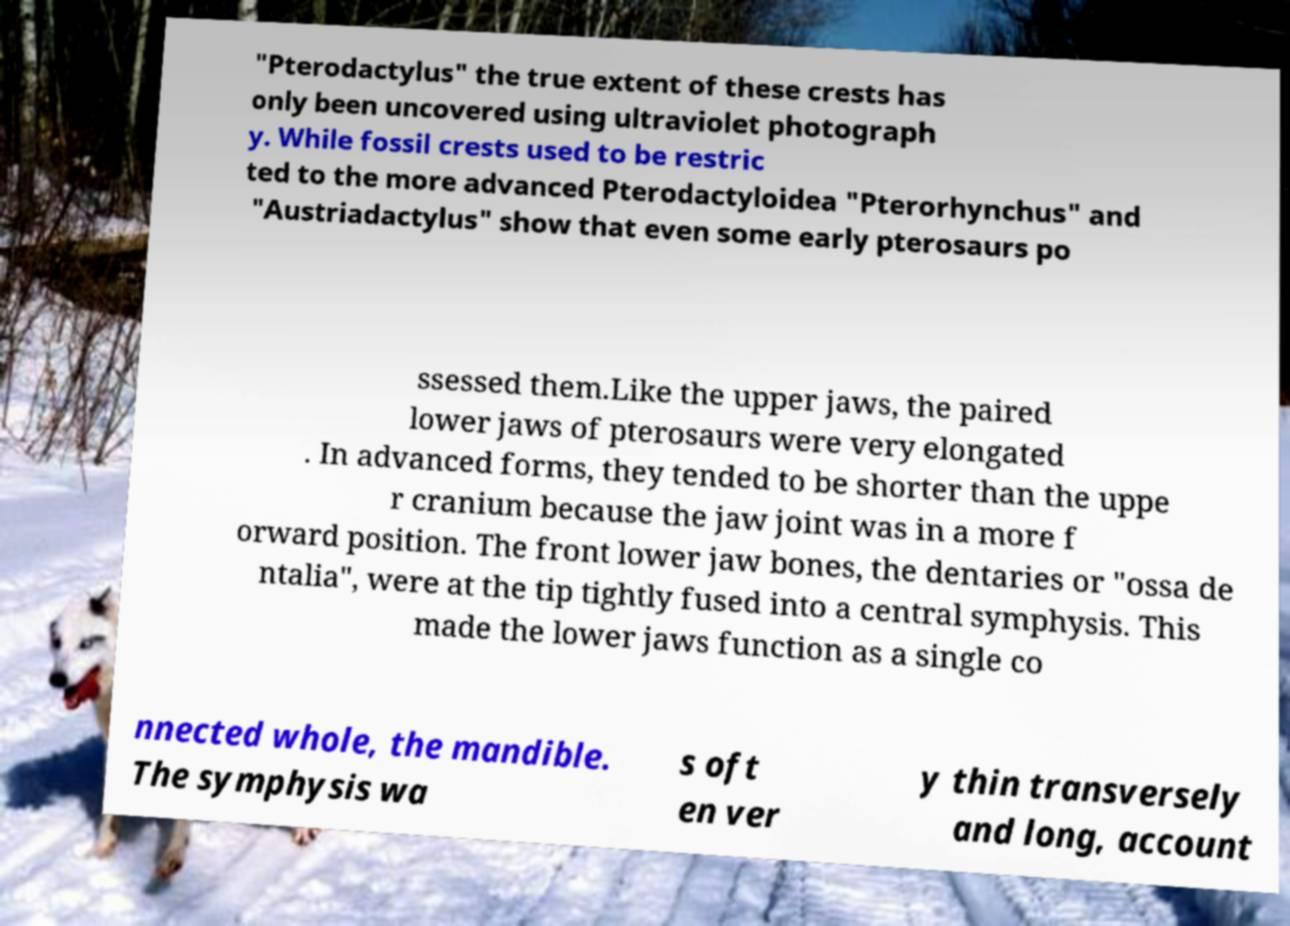Please identify and transcribe the text found in this image. "Pterodactylus" the true extent of these crests has only been uncovered using ultraviolet photograph y. While fossil crests used to be restric ted to the more advanced Pterodactyloidea "Pterorhynchus" and "Austriadactylus" show that even some early pterosaurs po ssessed them.Like the upper jaws, the paired lower jaws of pterosaurs were very elongated . In advanced forms, they tended to be shorter than the uppe r cranium because the jaw joint was in a more f orward position. The front lower jaw bones, the dentaries or "ossa de ntalia", were at the tip tightly fused into a central symphysis. This made the lower jaws function as a single co nnected whole, the mandible. The symphysis wa s oft en ver y thin transversely and long, account 